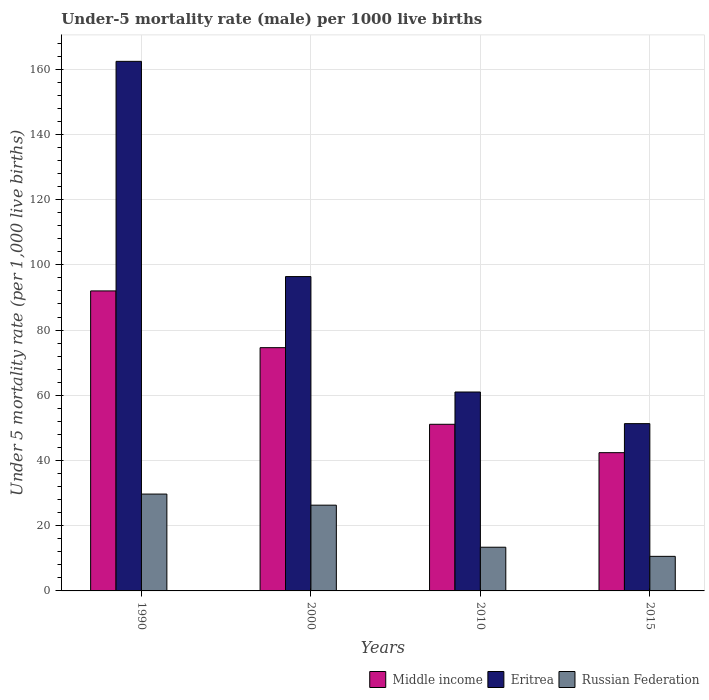How many different coloured bars are there?
Offer a terse response. 3. Are the number of bars per tick equal to the number of legend labels?
Your response must be concise. Yes. Are the number of bars on each tick of the X-axis equal?
Provide a succinct answer. Yes. What is the label of the 1st group of bars from the left?
Your answer should be compact. 1990. In how many cases, is the number of bars for a given year not equal to the number of legend labels?
Ensure brevity in your answer.  0. What is the under-five mortality rate in Eritrea in 2010?
Provide a succinct answer. 61. Across all years, what is the maximum under-five mortality rate in Russian Federation?
Make the answer very short. 29.7. Across all years, what is the minimum under-five mortality rate in Middle income?
Ensure brevity in your answer.  42.4. In which year was the under-five mortality rate in Russian Federation maximum?
Provide a succinct answer. 1990. In which year was the under-five mortality rate in Eritrea minimum?
Your answer should be compact. 2015. What is the total under-five mortality rate in Middle income in the graph?
Ensure brevity in your answer.  260.1. What is the difference between the under-five mortality rate in Middle income in 2000 and that in 2015?
Offer a very short reply. 32.2. What is the difference between the under-five mortality rate in Russian Federation in 2000 and the under-five mortality rate in Eritrea in 2010?
Offer a very short reply. -34.7. What is the average under-five mortality rate in Middle income per year?
Offer a very short reply. 65.02. In the year 2015, what is the difference between the under-five mortality rate in Middle income and under-five mortality rate in Eritrea?
Offer a terse response. -8.9. In how many years, is the under-five mortality rate in Eritrea greater than 140?
Offer a terse response. 1. What is the ratio of the under-five mortality rate in Eritrea in 2000 to that in 2015?
Offer a very short reply. 1.88. Is the difference between the under-five mortality rate in Middle income in 2000 and 2015 greater than the difference between the under-five mortality rate in Eritrea in 2000 and 2015?
Keep it short and to the point. No. What is the difference between the highest and the second highest under-five mortality rate in Middle income?
Your response must be concise. 17.4. What is the difference between the highest and the lowest under-five mortality rate in Eritrea?
Offer a terse response. 111.1. In how many years, is the under-five mortality rate in Eritrea greater than the average under-five mortality rate in Eritrea taken over all years?
Give a very brief answer. 2. What does the 2nd bar from the right in 2015 represents?
Your answer should be compact. Eritrea. Is it the case that in every year, the sum of the under-five mortality rate in Middle income and under-five mortality rate in Russian Federation is greater than the under-five mortality rate in Eritrea?
Provide a short and direct response. No. How many bars are there?
Offer a terse response. 12. Are the values on the major ticks of Y-axis written in scientific E-notation?
Provide a short and direct response. No. What is the title of the graph?
Your answer should be compact. Under-5 mortality rate (male) per 1000 live births. What is the label or title of the Y-axis?
Provide a succinct answer. Under 5 mortality rate (per 1,0 live births). What is the Under 5 mortality rate (per 1,000 live births) of Middle income in 1990?
Your answer should be very brief. 92. What is the Under 5 mortality rate (per 1,000 live births) of Eritrea in 1990?
Make the answer very short. 162.4. What is the Under 5 mortality rate (per 1,000 live births) of Russian Federation in 1990?
Offer a terse response. 29.7. What is the Under 5 mortality rate (per 1,000 live births) of Middle income in 2000?
Your answer should be very brief. 74.6. What is the Under 5 mortality rate (per 1,000 live births) in Eritrea in 2000?
Make the answer very short. 96.4. What is the Under 5 mortality rate (per 1,000 live births) in Russian Federation in 2000?
Ensure brevity in your answer.  26.3. What is the Under 5 mortality rate (per 1,000 live births) of Middle income in 2010?
Your answer should be very brief. 51.1. What is the Under 5 mortality rate (per 1,000 live births) in Russian Federation in 2010?
Your answer should be very brief. 13.4. What is the Under 5 mortality rate (per 1,000 live births) of Middle income in 2015?
Make the answer very short. 42.4. What is the Under 5 mortality rate (per 1,000 live births) of Eritrea in 2015?
Your response must be concise. 51.3. Across all years, what is the maximum Under 5 mortality rate (per 1,000 live births) of Middle income?
Ensure brevity in your answer.  92. Across all years, what is the maximum Under 5 mortality rate (per 1,000 live births) of Eritrea?
Your response must be concise. 162.4. Across all years, what is the maximum Under 5 mortality rate (per 1,000 live births) in Russian Federation?
Make the answer very short. 29.7. Across all years, what is the minimum Under 5 mortality rate (per 1,000 live births) in Middle income?
Offer a terse response. 42.4. Across all years, what is the minimum Under 5 mortality rate (per 1,000 live births) in Eritrea?
Provide a succinct answer. 51.3. What is the total Under 5 mortality rate (per 1,000 live births) in Middle income in the graph?
Offer a very short reply. 260.1. What is the total Under 5 mortality rate (per 1,000 live births) in Eritrea in the graph?
Your response must be concise. 371.1. What is the difference between the Under 5 mortality rate (per 1,000 live births) of Russian Federation in 1990 and that in 2000?
Your response must be concise. 3.4. What is the difference between the Under 5 mortality rate (per 1,000 live births) in Middle income in 1990 and that in 2010?
Give a very brief answer. 40.9. What is the difference between the Under 5 mortality rate (per 1,000 live births) in Eritrea in 1990 and that in 2010?
Provide a succinct answer. 101.4. What is the difference between the Under 5 mortality rate (per 1,000 live births) in Russian Federation in 1990 and that in 2010?
Offer a terse response. 16.3. What is the difference between the Under 5 mortality rate (per 1,000 live births) in Middle income in 1990 and that in 2015?
Ensure brevity in your answer.  49.6. What is the difference between the Under 5 mortality rate (per 1,000 live births) of Eritrea in 1990 and that in 2015?
Your answer should be compact. 111.1. What is the difference between the Under 5 mortality rate (per 1,000 live births) of Russian Federation in 1990 and that in 2015?
Provide a succinct answer. 19.1. What is the difference between the Under 5 mortality rate (per 1,000 live births) in Eritrea in 2000 and that in 2010?
Provide a succinct answer. 35.4. What is the difference between the Under 5 mortality rate (per 1,000 live births) of Russian Federation in 2000 and that in 2010?
Provide a short and direct response. 12.9. What is the difference between the Under 5 mortality rate (per 1,000 live births) in Middle income in 2000 and that in 2015?
Offer a very short reply. 32.2. What is the difference between the Under 5 mortality rate (per 1,000 live births) of Eritrea in 2000 and that in 2015?
Offer a very short reply. 45.1. What is the difference between the Under 5 mortality rate (per 1,000 live births) in Eritrea in 2010 and that in 2015?
Provide a short and direct response. 9.7. What is the difference between the Under 5 mortality rate (per 1,000 live births) of Middle income in 1990 and the Under 5 mortality rate (per 1,000 live births) of Russian Federation in 2000?
Your answer should be compact. 65.7. What is the difference between the Under 5 mortality rate (per 1,000 live births) in Eritrea in 1990 and the Under 5 mortality rate (per 1,000 live births) in Russian Federation in 2000?
Offer a very short reply. 136.1. What is the difference between the Under 5 mortality rate (per 1,000 live births) of Middle income in 1990 and the Under 5 mortality rate (per 1,000 live births) of Russian Federation in 2010?
Provide a succinct answer. 78.6. What is the difference between the Under 5 mortality rate (per 1,000 live births) of Eritrea in 1990 and the Under 5 mortality rate (per 1,000 live births) of Russian Federation in 2010?
Offer a terse response. 149. What is the difference between the Under 5 mortality rate (per 1,000 live births) in Middle income in 1990 and the Under 5 mortality rate (per 1,000 live births) in Eritrea in 2015?
Offer a terse response. 40.7. What is the difference between the Under 5 mortality rate (per 1,000 live births) of Middle income in 1990 and the Under 5 mortality rate (per 1,000 live births) of Russian Federation in 2015?
Make the answer very short. 81.4. What is the difference between the Under 5 mortality rate (per 1,000 live births) in Eritrea in 1990 and the Under 5 mortality rate (per 1,000 live births) in Russian Federation in 2015?
Provide a short and direct response. 151.8. What is the difference between the Under 5 mortality rate (per 1,000 live births) of Middle income in 2000 and the Under 5 mortality rate (per 1,000 live births) of Eritrea in 2010?
Make the answer very short. 13.6. What is the difference between the Under 5 mortality rate (per 1,000 live births) of Middle income in 2000 and the Under 5 mortality rate (per 1,000 live births) of Russian Federation in 2010?
Provide a succinct answer. 61.2. What is the difference between the Under 5 mortality rate (per 1,000 live births) in Eritrea in 2000 and the Under 5 mortality rate (per 1,000 live births) in Russian Federation in 2010?
Provide a short and direct response. 83. What is the difference between the Under 5 mortality rate (per 1,000 live births) in Middle income in 2000 and the Under 5 mortality rate (per 1,000 live births) in Eritrea in 2015?
Your answer should be compact. 23.3. What is the difference between the Under 5 mortality rate (per 1,000 live births) of Eritrea in 2000 and the Under 5 mortality rate (per 1,000 live births) of Russian Federation in 2015?
Provide a short and direct response. 85.8. What is the difference between the Under 5 mortality rate (per 1,000 live births) of Middle income in 2010 and the Under 5 mortality rate (per 1,000 live births) of Russian Federation in 2015?
Your answer should be very brief. 40.5. What is the difference between the Under 5 mortality rate (per 1,000 live births) of Eritrea in 2010 and the Under 5 mortality rate (per 1,000 live births) of Russian Federation in 2015?
Offer a very short reply. 50.4. What is the average Under 5 mortality rate (per 1,000 live births) of Middle income per year?
Ensure brevity in your answer.  65.03. What is the average Under 5 mortality rate (per 1,000 live births) of Eritrea per year?
Offer a very short reply. 92.78. In the year 1990, what is the difference between the Under 5 mortality rate (per 1,000 live births) of Middle income and Under 5 mortality rate (per 1,000 live births) of Eritrea?
Provide a short and direct response. -70.4. In the year 1990, what is the difference between the Under 5 mortality rate (per 1,000 live births) in Middle income and Under 5 mortality rate (per 1,000 live births) in Russian Federation?
Give a very brief answer. 62.3. In the year 1990, what is the difference between the Under 5 mortality rate (per 1,000 live births) of Eritrea and Under 5 mortality rate (per 1,000 live births) of Russian Federation?
Give a very brief answer. 132.7. In the year 2000, what is the difference between the Under 5 mortality rate (per 1,000 live births) of Middle income and Under 5 mortality rate (per 1,000 live births) of Eritrea?
Your response must be concise. -21.8. In the year 2000, what is the difference between the Under 5 mortality rate (per 1,000 live births) of Middle income and Under 5 mortality rate (per 1,000 live births) of Russian Federation?
Provide a succinct answer. 48.3. In the year 2000, what is the difference between the Under 5 mortality rate (per 1,000 live births) of Eritrea and Under 5 mortality rate (per 1,000 live births) of Russian Federation?
Provide a short and direct response. 70.1. In the year 2010, what is the difference between the Under 5 mortality rate (per 1,000 live births) in Middle income and Under 5 mortality rate (per 1,000 live births) in Eritrea?
Provide a succinct answer. -9.9. In the year 2010, what is the difference between the Under 5 mortality rate (per 1,000 live births) in Middle income and Under 5 mortality rate (per 1,000 live births) in Russian Federation?
Ensure brevity in your answer.  37.7. In the year 2010, what is the difference between the Under 5 mortality rate (per 1,000 live births) in Eritrea and Under 5 mortality rate (per 1,000 live births) in Russian Federation?
Keep it short and to the point. 47.6. In the year 2015, what is the difference between the Under 5 mortality rate (per 1,000 live births) in Middle income and Under 5 mortality rate (per 1,000 live births) in Eritrea?
Offer a terse response. -8.9. In the year 2015, what is the difference between the Under 5 mortality rate (per 1,000 live births) of Middle income and Under 5 mortality rate (per 1,000 live births) of Russian Federation?
Your response must be concise. 31.8. In the year 2015, what is the difference between the Under 5 mortality rate (per 1,000 live births) in Eritrea and Under 5 mortality rate (per 1,000 live births) in Russian Federation?
Keep it short and to the point. 40.7. What is the ratio of the Under 5 mortality rate (per 1,000 live births) in Middle income in 1990 to that in 2000?
Provide a succinct answer. 1.23. What is the ratio of the Under 5 mortality rate (per 1,000 live births) of Eritrea in 1990 to that in 2000?
Your response must be concise. 1.68. What is the ratio of the Under 5 mortality rate (per 1,000 live births) in Russian Federation in 1990 to that in 2000?
Provide a succinct answer. 1.13. What is the ratio of the Under 5 mortality rate (per 1,000 live births) of Middle income in 1990 to that in 2010?
Offer a terse response. 1.8. What is the ratio of the Under 5 mortality rate (per 1,000 live births) in Eritrea in 1990 to that in 2010?
Your answer should be very brief. 2.66. What is the ratio of the Under 5 mortality rate (per 1,000 live births) in Russian Federation in 1990 to that in 2010?
Offer a very short reply. 2.22. What is the ratio of the Under 5 mortality rate (per 1,000 live births) in Middle income in 1990 to that in 2015?
Keep it short and to the point. 2.17. What is the ratio of the Under 5 mortality rate (per 1,000 live births) in Eritrea in 1990 to that in 2015?
Keep it short and to the point. 3.17. What is the ratio of the Under 5 mortality rate (per 1,000 live births) in Russian Federation in 1990 to that in 2015?
Ensure brevity in your answer.  2.8. What is the ratio of the Under 5 mortality rate (per 1,000 live births) in Middle income in 2000 to that in 2010?
Offer a very short reply. 1.46. What is the ratio of the Under 5 mortality rate (per 1,000 live births) of Eritrea in 2000 to that in 2010?
Your response must be concise. 1.58. What is the ratio of the Under 5 mortality rate (per 1,000 live births) of Russian Federation in 2000 to that in 2010?
Your answer should be very brief. 1.96. What is the ratio of the Under 5 mortality rate (per 1,000 live births) of Middle income in 2000 to that in 2015?
Keep it short and to the point. 1.76. What is the ratio of the Under 5 mortality rate (per 1,000 live births) of Eritrea in 2000 to that in 2015?
Your response must be concise. 1.88. What is the ratio of the Under 5 mortality rate (per 1,000 live births) of Russian Federation in 2000 to that in 2015?
Keep it short and to the point. 2.48. What is the ratio of the Under 5 mortality rate (per 1,000 live births) of Middle income in 2010 to that in 2015?
Provide a succinct answer. 1.21. What is the ratio of the Under 5 mortality rate (per 1,000 live births) in Eritrea in 2010 to that in 2015?
Offer a very short reply. 1.19. What is the ratio of the Under 5 mortality rate (per 1,000 live births) of Russian Federation in 2010 to that in 2015?
Provide a short and direct response. 1.26. What is the difference between the highest and the lowest Under 5 mortality rate (per 1,000 live births) of Middle income?
Your answer should be compact. 49.6. What is the difference between the highest and the lowest Under 5 mortality rate (per 1,000 live births) of Eritrea?
Offer a very short reply. 111.1. What is the difference between the highest and the lowest Under 5 mortality rate (per 1,000 live births) of Russian Federation?
Provide a short and direct response. 19.1. 